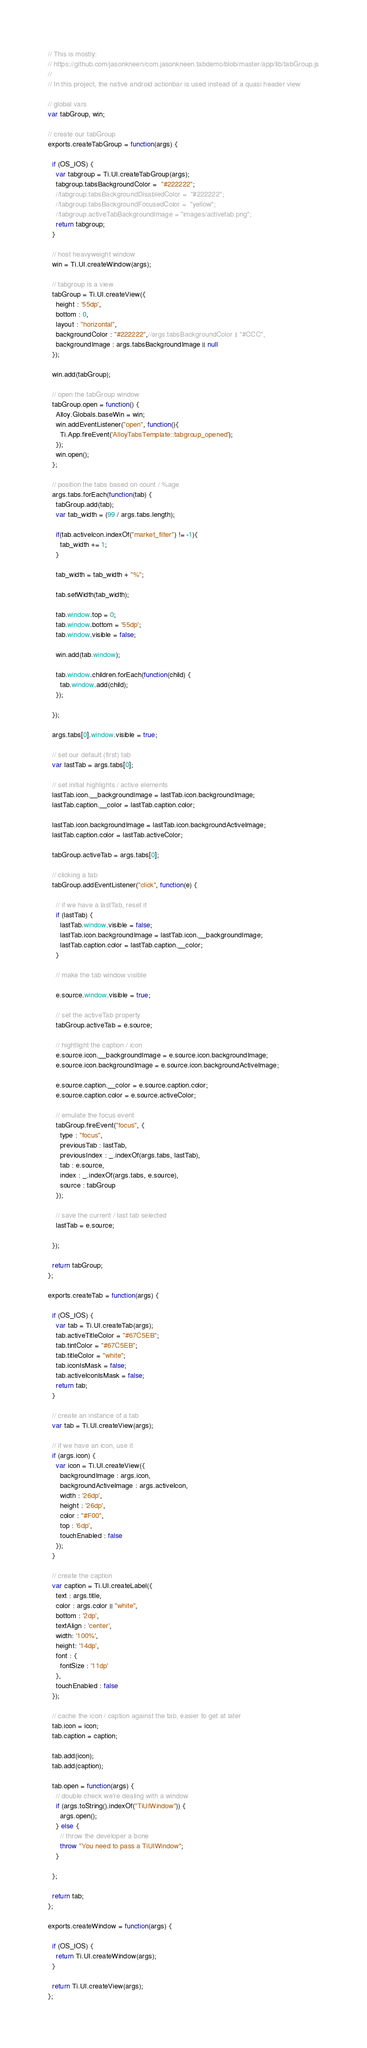Convert code to text. <code><loc_0><loc_0><loc_500><loc_500><_JavaScript_>// This is mostly: 
// https://github.com/jasonkneen/com.jasonkneen.tabdemo/blob/master/app/lib/tabGroup.js
// 
// In this project, the native android actionbar is used instead of a quasi header view

// global vars
var tabGroup, win;

// create our tabGroup
exports.createTabGroup = function(args) {

  if (OS_IOS) {
  	var tabgroup = Ti.UI.createTabGroup(args);
  	tabgroup.tabsBackgroundColor =  "#222222";
  	//tabgroup.tabsBackgroundDisabledColor =  "#222222";
  	//tabgroup.tabsBackgroundFocusedColor =  "yellow";
  	//tabgroup.activeTabBackgroundImage = "images/activetab.png";
    return tabgroup;  
  }

  // host heavyweight window
  win = Ti.UI.createWindow(args);

  // tabgroup is a view
  tabGroup = Ti.UI.createView({
    height : '55dp',
    bottom : 0,
    layout : "horizontal",
    backgroundColor : "#222222",//args.tabsBackgroundColor || "#CCC",
    backgroundImage : args.tabsBackgroundImage || null
  });

  win.add(tabGroup);

  // open the tabGroup window
  tabGroup.open = function() {
    Alloy.Globals.baseWin = win;
    win.addEventListener("open", function(){
      Ti.App.fireEvent('AlloyTabsTemplate::tabgroup_opened');
    });
    win.open();
  };

  // position the tabs based on count / %age
  args.tabs.forEach(function(tab) {
    tabGroup.add(tab);
    var tab_width = (99 / args.tabs.length);

    if(tab.activeIcon.indexOf("market_filter") != -1){
      tab_width += 1;
    }

    tab_width = tab_width + "%";
    
    tab.setWidth(tab_width);

    tab.window.top = 0;
    tab.window.bottom = '55dp';
    tab.window.visible = false;

    win.add(tab.window);

    tab.window.children.forEach(function(child) {
      tab.window.add(child);
    });

  });

  args.tabs[0].window.visible = true;

  // set our default (first) tab
  var lastTab = args.tabs[0];

  // set initial highlights / active elements
  lastTab.icon.__backgroundImage = lastTab.icon.backgroundImage;
  lastTab.caption.__color = lastTab.caption.color;

  lastTab.icon.backgroundImage = lastTab.icon.backgroundActiveImage;
  lastTab.caption.color = lastTab.activeColor;

  tabGroup.activeTab = args.tabs[0];

  // clicking a tab
  tabGroup.addEventListener("click", function(e) {

    // if we have a lastTab, reset it
    if (lastTab) {
      lastTab.window.visible = false;
      lastTab.icon.backgroundImage = lastTab.icon.__backgroundImage;
      lastTab.caption.color = lastTab.caption.__color;
    }

    // make the tab window visible

    e.source.window.visible = true;

    // set the activeTab property
    tabGroup.activeTab = e.source;

    // hightlight the caption / icon
    e.source.icon.__backgroundImage = e.source.icon.backgroundImage;
    e.source.icon.backgroundImage = e.source.icon.backgroundActiveImage;

    e.source.caption.__color = e.source.caption.color;
    e.source.caption.color = e.source.activeColor;

    // emulate the focus event
    tabGroup.fireEvent("focus", {
      type : "focus",
      previousTab : lastTab,
      previousIndex : _.indexOf(args.tabs, lastTab),
      tab : e.source,
      index : _.indexOf(args.tabs, e.source),
      source : tabGroup
    });

    // save the current / last tab selected
    lastTab = e.source;

  });

  return tabGroup;
};

exports.createTab = function(args) {

  if (OS_IOS) {
  	var tab = Ti.UI.createTab(args);
  	tab.activeTitleColor = "#67C5EB";
  	tab.tintColor = "#67C5EB";
  	tab.titleColor = "white";
  	tab.iconIsMask = false;
  	tab.activeIconIsMask = false;
    return tab;
  }

  // create an instance of a tab
  var tab = Ti.UI.createView(args);

  // if we have an icon, use it
  if (args.icon) {
    var icon = Ti.UI.createView({
      backgroundImage : args.icon,
      backgroundActiveImage : args.activeIcon,
      width : '26dp',
      height : '26dp',
      color : "#F00",
      top : '6dp',
      touchEnabled : false
    });
  }

  // create the caption
  var caption = Ti.UI.createLabel({
    text : args.title,
    color : args.color || "white",
    bottom : '2dp',
    textAlign : 'center',
    width: '100%',
    height: '14dp',
    font : {
      fontSize : '11dp'
    },
    touchEnabled : false
  });

  // cache the icon / caption against the tab, easier to get at later
  tab.icon = icon;
  tab.caption = caption;

  tab.add(icon);
  tab.add(caption);

  tab.open = function(args) {
    // double check we're dealing with a window
    if (args.toString().indexOf("TiUIWindow")) {
      args.open();
    } else {
      // throw the developer a bone
      throw "You need to pass a TiUIWindow";
    }

  };

  return tab;
};

exports.createWindow = function(args) {

  if (OS_IOS) {
    return Ti.UI.createWindow(args);
  }

  return Ti.UI.createView(args);
};</code> 